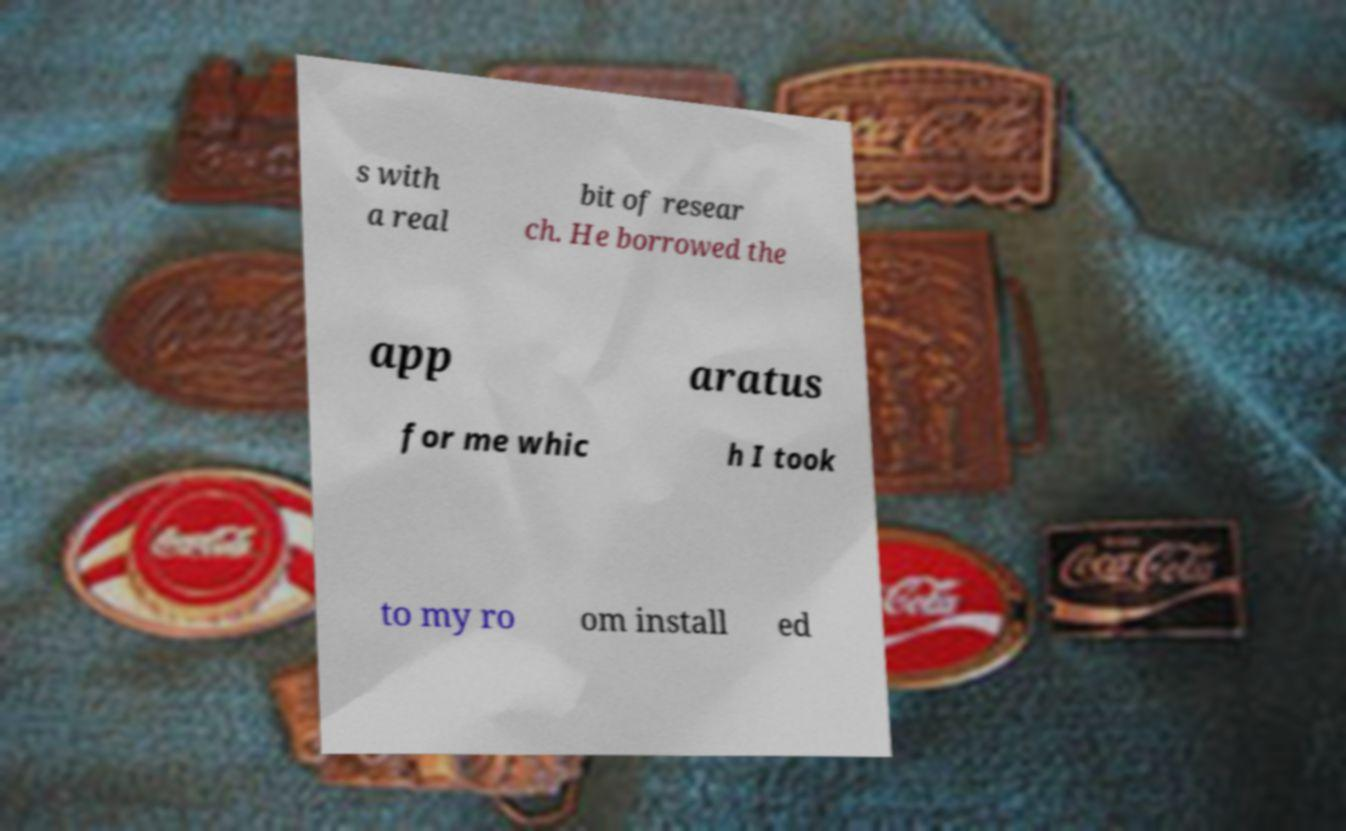Could you assist in decoding the text presented in this image and type it out clearly? s with a real bit of resear ch. He borrowed the app aratus for me whic h I took to my ro om install ed 